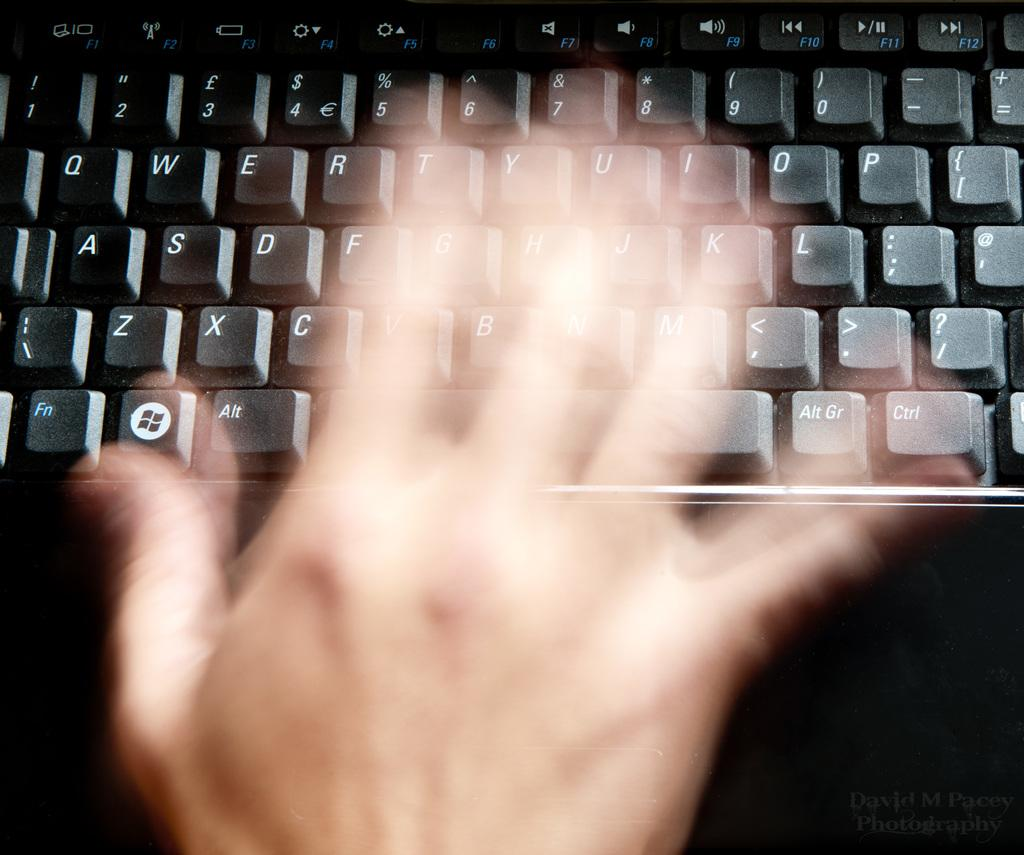<image>
Write a terse but informative summary of the picture. QWERTY standard keys are shown on this keyboard. 